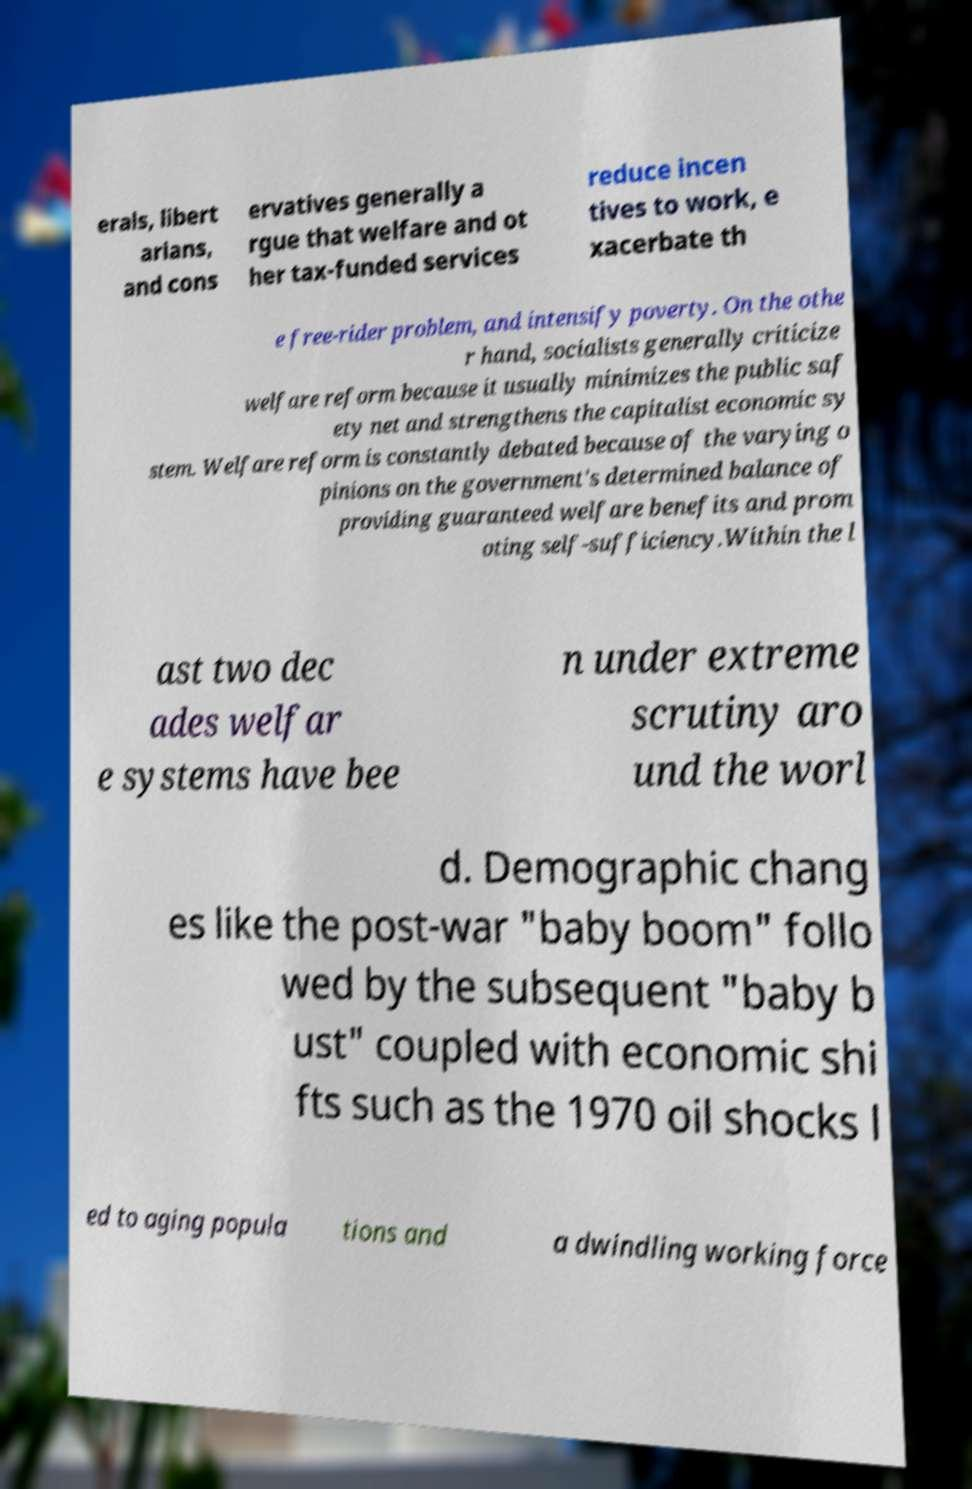Please identify and transcribe the text found in this image. erals, libert arians, and cons ervatives generally a rgue that welfare and ot her tax-funded services reduce incen tives to work, e xacerbate th e free-rider problem, and intensify poverty. On the othe r hand, socialists generally criticize welfare reform because it usually minimizes the public saf ety net and strengthens the capitalist economic sy stem. Welfare reform is constantly debated because of the varying o pinions on the government's determined balance of providing guaranteed welfare benefits and prom oting self-sufficiency.Within the l ast two dec ades welfar e systems have bee n under extreme scrutiny aro und the worl d. Demographic chang es like the post-war "baby boom" follo wed by the subsequent "baby b ust" coupled with economic shi fts such as the 1970 oil shocks l ed to aging popula tions and a dwindling working force 